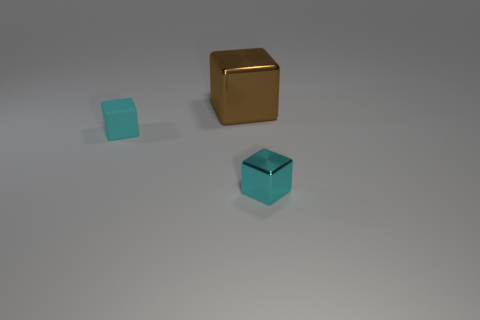Add 1 brown objects. How many objects exist? 4 Subtract all cyan balls. Subtract all big metal things. How many objects are left? 2 Add 1 big shiny cubes. How many big shiny cubes are left? 2 Add 1 metallic balls. How many metallic balls exist? 1 Subtract 0 yellow cylinders. How many objects are left? 3 